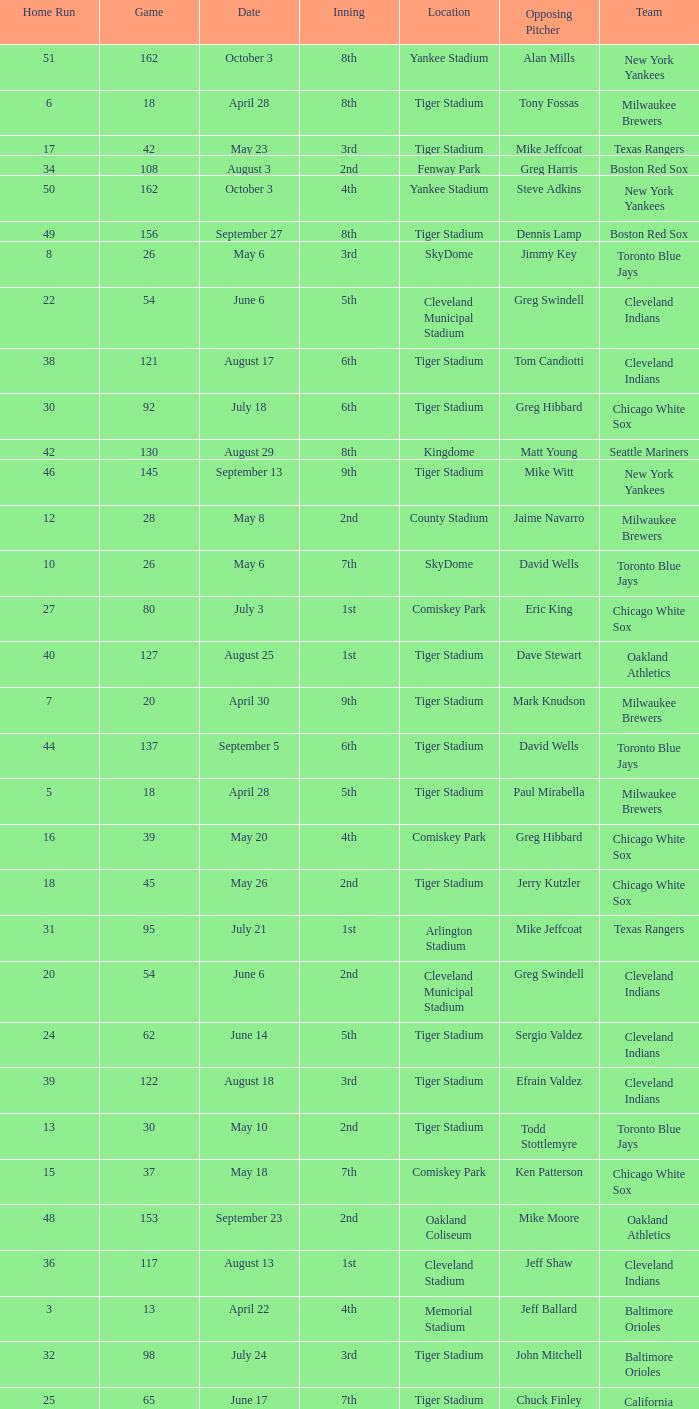When Efrain Valdez was pitching, what was the highest home run? 39.0. 